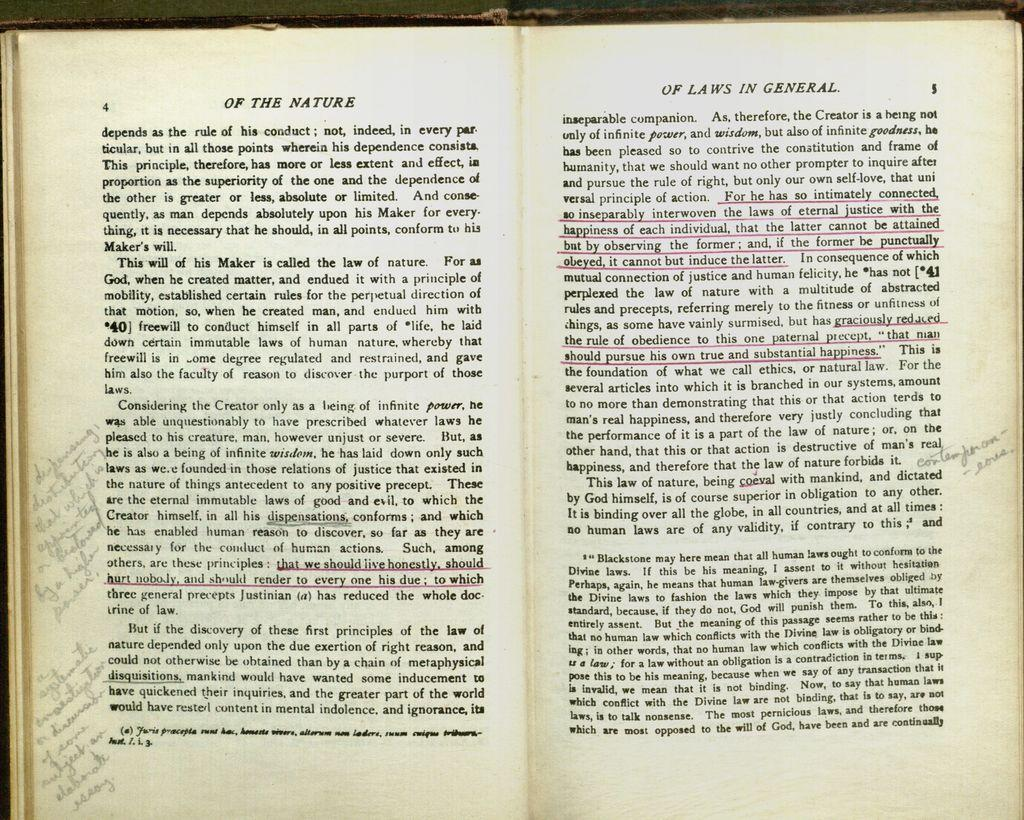<image>
Present a compact description of the photo's key features. Book pages detailing the laws of nature and the laws in general. 